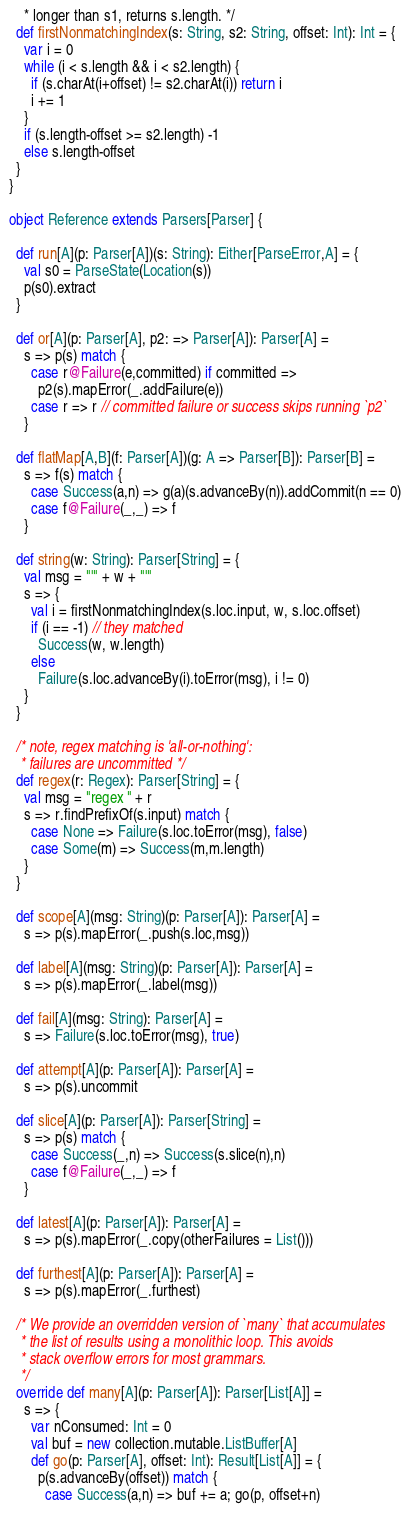<code> <loc_0><loc_0><loc_500><loc_500><_Scala_>    * longer than s1, returns s.length. */
  def firstNonmatchingIndex(s: String, s2: String, offset: Int): Int = {
    var i = 0
    while (i < s.length && i < s2.length) {
      if (s.charAt(i+offset) != s2.charAt(i)) return i
      i += 1
    }
    if (s.length-offset >= s2.length) -1
    else s.length-offset 
  }
}

object Reference extends Parsers[Parser] {
  
  def run[A](p: Parser[A])(s: String): Either[ParseError,A] = {
    val s0 = ParseState(Location(s)) 
    p(s0).extract
  }

  def or[A](p: Parser[A], p2: => Parser[A]): Parser[A] = 
    s => p(s) match {
      case r@Failure(e,committed) if committed => 
        p2(s).mapError(_.addFailure(e))
      case r => r // committed failure or success skips running `p2` 
    } 

  def flatMap[A,B](f: Parser[A])(g: A => Parser[B]): Parser[B] =
    s => f(s) match {
      case Success(a,n) => g(a)(s.advanceBy(n)).addCommit(n == 0)
      case f@Failure(_,_) => f
    }
 
  def string(w: String): Parser[String] = {
    val msg = "'" + w + "'" 
    s => {
      val i = firstNonmatchingIndex(s.loc.input, w, s.loc.offset) 
      if (i == -1) // they matched
        Success(w, w.length)
      else
        Failure(s.loc.advanceBy(i).toError(msg), i != 0)
    }
  }
 
  /* note, regex matching is 'all-or-nothing':
   * failures are uncommitted */
  def regex(r: Regex): Parser[String] = {
    val msg = "regex " + r
    s => r.findPrefixOf(s.input) match {
      case None => Failure(s.loc.toError(msg), false)
      case Some(m) => Success(m,m.length)
    }
  }

  def scope[A](msg: String)(p: Parser[A]): Parser[A] = 
    s => p(s).mapError(_.push(s.loc,msg))

  def label[A](msg: String)(p: Parser[A]): Parser[A] = 
    s => p(s).mapError(_.label(msg))

  def fail[A](msg: String): Parser[A] = 
    s => Failure(s.loc.toError(msg), true) 

  def attempt[A](p: Parser[A]): Parser[A] = 
    s => p(s).uncommit

  def slice[A](p: Parser[A]): Parser[String] = 
    s => p(s) match {
      case Success(_,n) => Success(s.slice(n),n)
      case f@Failure(_,_) => f
    }

  def latest[A](p: Parser[A]): Parser[A] = 
    s => p(s).mapError(_.copy(otherFailures = List()))

  def furthest[A](p: Parser[A]): Parser[A] = 
    s => p(s).mapError(_.furthest)

  /* We provide an overridden version of `many` that accumulates
   * the list of results using a monolithic loop. This avoids 
   * stack overflow errors for most grammars. 
   */
  override def many[A](p: Parser[A]): Parser[List[A]] = 
    s => {
      var nConsumed: Int = 0
      val buf = new collection.mutable.ListBuffer[A]
      def go(p: Parser[A], offset: Int): Result[List[A]] = {
        p(s.advanceBy(offset)) match {
          case Success(a,n) => buf += a; go(p, offset+n) </code> 